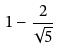<formula> <loc_0><loc_0><loc_500><loc_500>1 - \frac { 2 } { \sqrt { 5 } }</formula> 